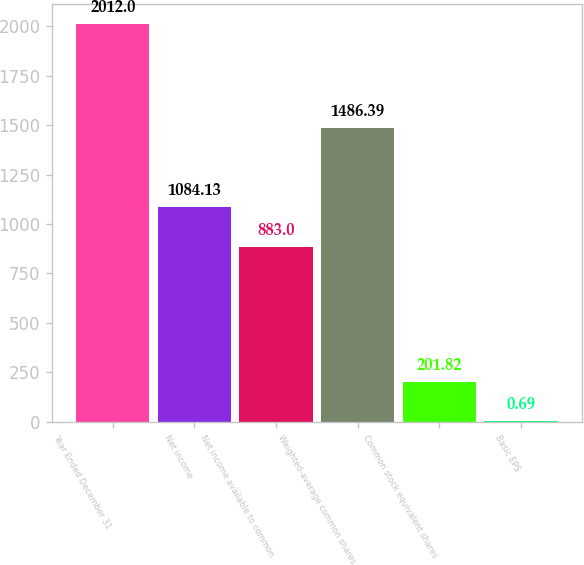<chart> <loc_0><loc_0><loc_500><loc_500><bar_chart><fcel>Year Ended December 31<fcel>Net income<fcel>Net income available to common<fcel>Weighted-average common shares<fcel>Common stock equivalent shares<fcel>Basic EPS<nl><fcel>2012<fcel>1084.13<fcel>883<fcel>1486.39<fcel>201.82<fcel>0.69<nl></chart> 